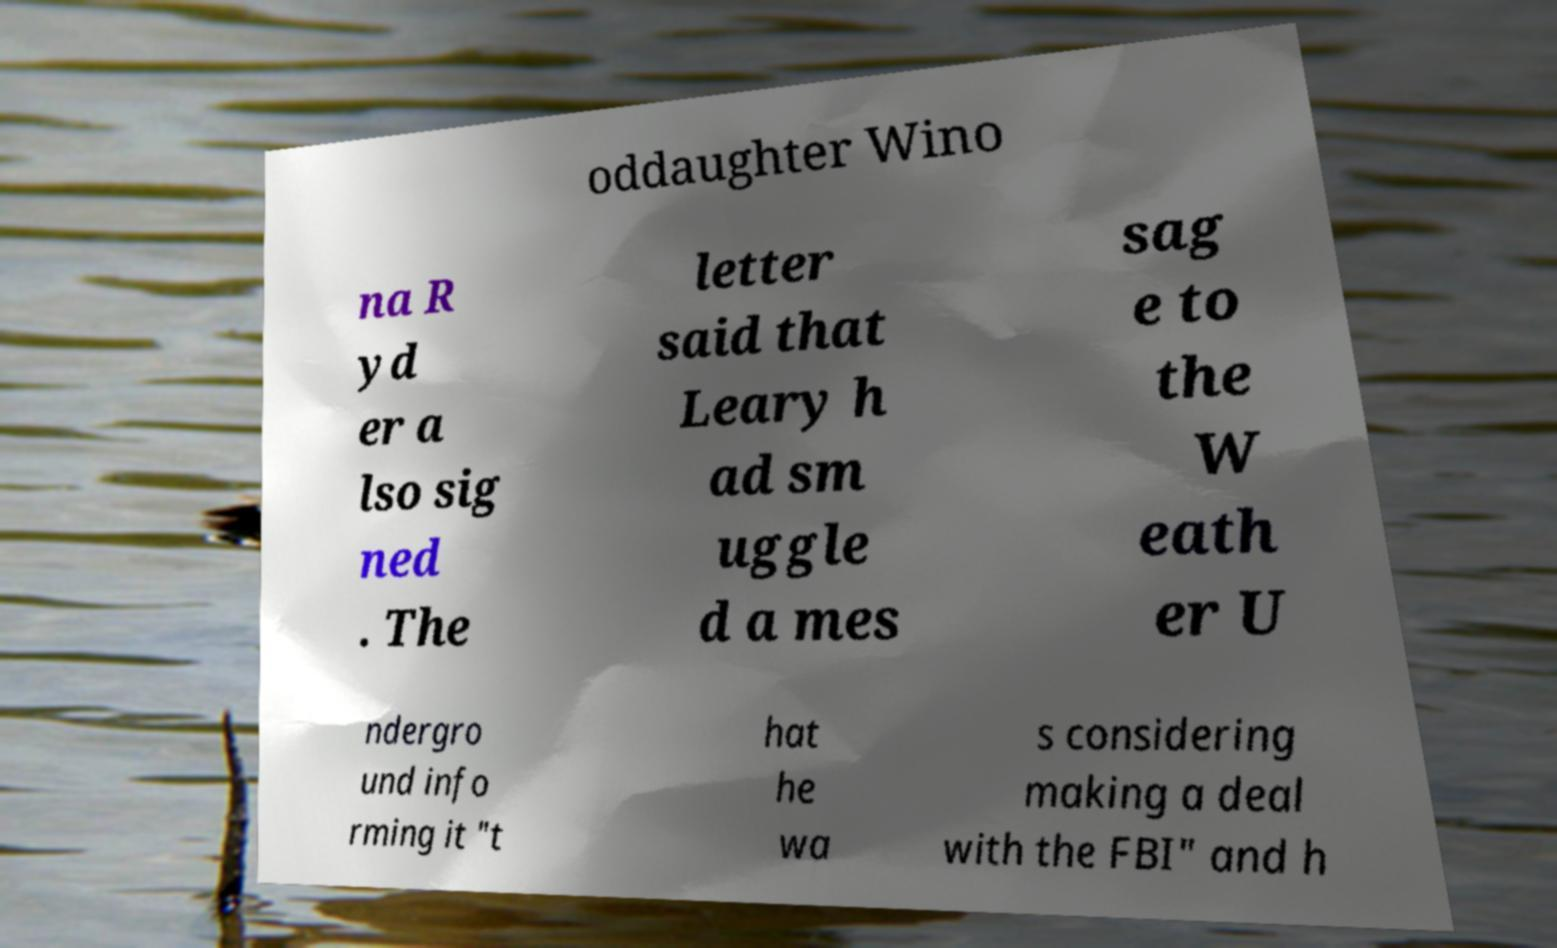There's text embedded in this image that I need extracted. Can you transcribe it verbatim? oddaughter Wino na R yd er a lso sig ned . The letter said that Leary h ad sm uggle d a mes sag e to the W eath er U ndergro und info rming it "t hat he wa s considering making a deal with the FBI" and h 